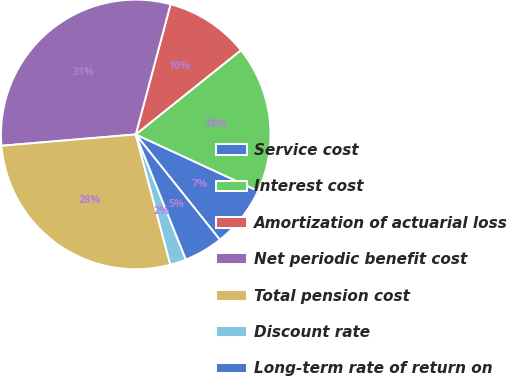<chart> <loc_0><loc_0><loc_500><loc_500><pie_chart><fcel>Service cost<fcel>Interest cost<fcel>Amortization of actuarial loss<fcel>Net periodic benefit cost<fcel>Total pension cost<fcel>Discount rate<fcel>Long-term rate of return on<nl><fcel>7.38%<fcel>17.64%<fcel>10.09%<fcel>30.5%<fcel>27.78%<fcel>1.94%<fcel>4.66%<nl></chart> 